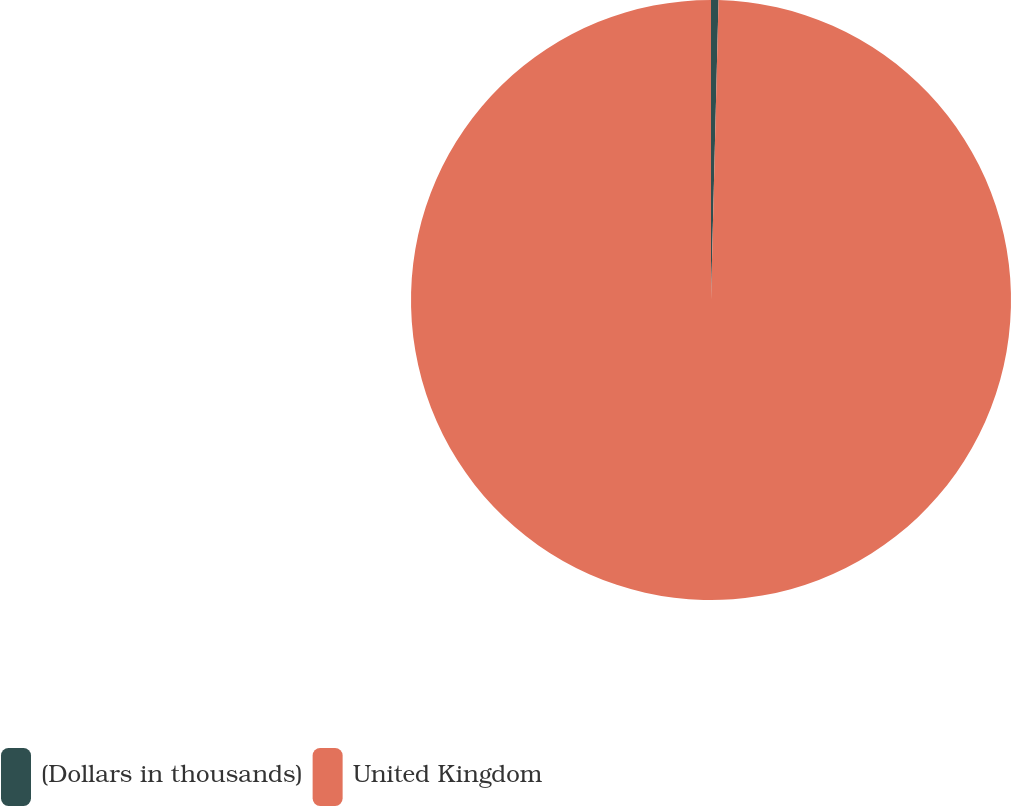Convert chart. <chart><loc_0><loc_0><loc_500><loc_500><pie_chart><fcel>(Dollars in thousands)<fcel>United Kingdom<nl><fcel>0.4%<fcel>99.6%<nl></chart> 